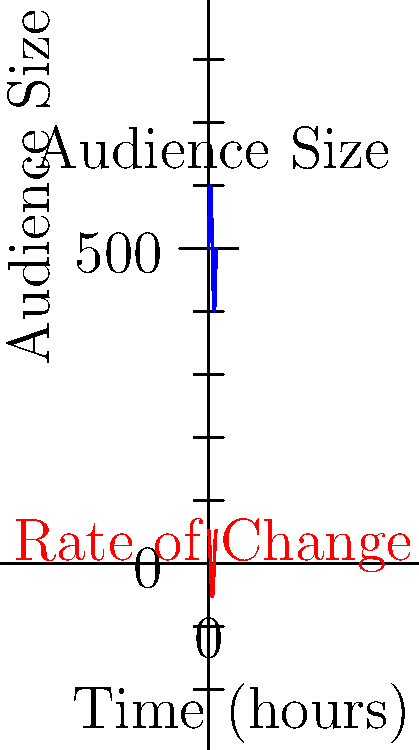At a bluegrass festival, the audience size $A(t)$ (in hundreds) varies over time $t$ (in hours) according to the function $A(t) = 5 + \sin(\frac{\pi t}{6})$. The rate of change of the audience size is given by $A'(t) = \frac{\pi}{6}\cos(\frac{\pi t}{6})$. At what time during the first 12 hours of the festival is the rate of change of the audience size at its maximum? To find the maximum rate of change, we need to analyze the derivative function $A'(t)$.

1. The rate of change is given by $A'(t) = \frac{\pi}{6}\cos(\frac{\pi t}{6})$.

2. The maximum value of cosine is 1, which occurs when its argument is a multiple of $2\pi$.

3. We need to solve: $\frac{\pi t}{6} = 2\pi n$, where $n$ is an integer.

4. Solving for $t$: $t = 12n$

5. Since we're only considering the first 12 hours, $n$ can only be 0 or 1.

6. When $n = 0$, $t = 0$, which is the start of the festival.

7. When $n = 1$, $t = 12$, which is the end of our time frame.

8. Both $t = 0$ and $t = 12$ give the maximum rate of change, but we typically choose the first occurrence.

Therefore, the rate of change of the audience size is at its maximum at the start of the festival, when $t = 0$ hours.
Answer: 0 hours 